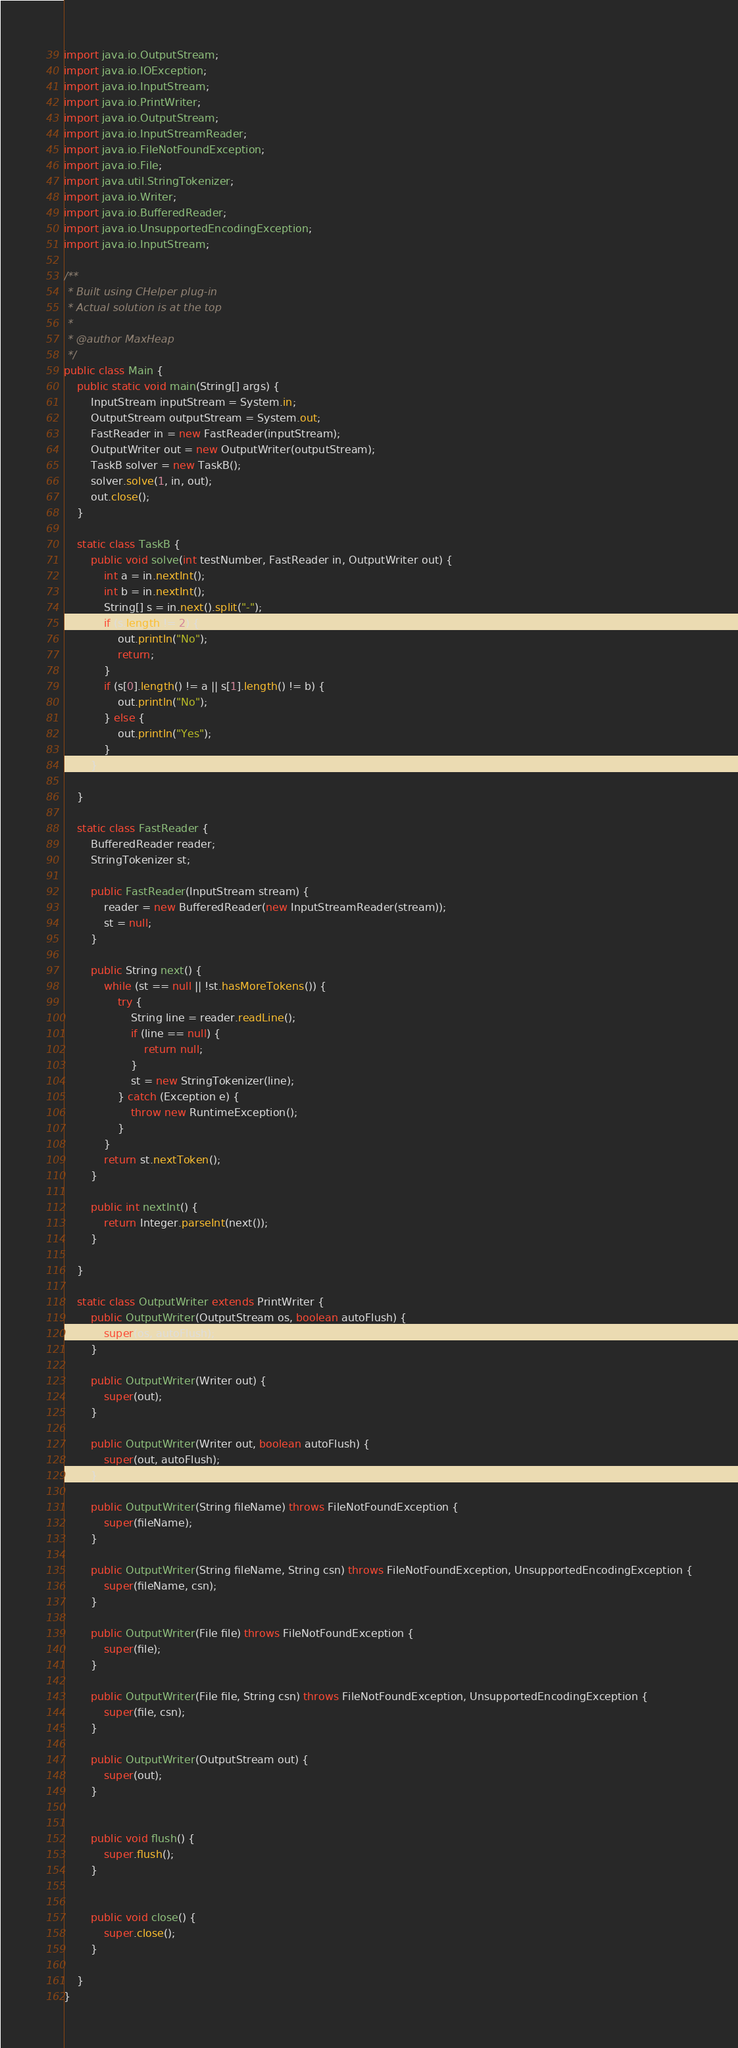Convert code to text. <code><loc_0><loc_0><loc_500><loc_500><_Java_>import java.io.OutputStream;
import java.io.IOException;
import java.io.InputStream;
import java.io.PrintWriter;
import java.io.OutputStream;
import java.io.InputStreamReader;
import java.io.FileNotFoundException;
import java.io.File;
import java.util.StringTokenizer;
import java.io.Writer;
import java.io.BufferedReader;
import java.io.UnsupportedEncodingException;
import java.io.InputStream;

/**
 * Built using CHelper plug-in
 * Actual solution is at the top
 *
 * @author MaxHeap
 */
public class Main {
    public static void main(String[] args) {
        InputStream inputStream = System.in;
        OutputStream outputStream = System.out;
        FastReader in = new FastReader(inputStream);
        OutputWriter out = new OutputWriter(outputStream);
        TaskB solver = new TaskB();
        solver.solve(1, in, out);
        out.close();
    }

    static class TaskB {
        public void solve(int testNumber, FastReader in, OutputWriter out) {
            int a = in.nextInt();
            int b = in.nextInt();
            String[] s = in.next().split("-");
            if (s.length != 2) {
                out.println("No");
                return;
            }
            if (s[0].length() != a || s[1].length() != b) {
                out.println("No");
            } else {
                out.println("Yes");
            }
        }

    }

    static class FastReader {
        BufferedReader reader;
        StringTokenizer st;

        public FastReader(InputStream stream) {
            reader = new BufferedReader(new InputStreamReader(stream));
            st = null;
        }

        public String next() {
            while (st == null || !st.hasMoreTokens()) {
                try {
                    String line = reader.readLine();
                    if (line == null) {
                        return null;
                    }
                    st = new StringTokenizer(line);
                } catch (Exception e) {
                    throw new RuntimeException();
                }
            }
            return st.nextToken();
        }

        public int nextInt() {
            return Integer.parseInt(next());
        }

    }

    static class OutputWriter extends PrintWriter {
        public OutputWriter(OutputStream os, boolean autoFlush) {
            super(os, autoFlush);
        }

        public OutputWriter(Writer out) {
            super(out);
        }

        public OutputWriter(Writer out, boolean autoFlush) {
            super(out, autoFlush);
        }

        public OutputWriter(String fileName) throws FileNotFoundException {
            super(fileName);
        }

        public OutputWriter(String fileName, String csn) throws FileNotFoundException, UnsupportedEncodingException {
            super(fileName, csn);
        }

        public OutputWriter(File file) throws FileNotFoundException {
            super(file);
        }

        public OutputWriter(File file, String csn) throws FileNotFoundException, UnsupportedEncodingException {
            super(file, csn);
        }

        public OutputWriter(OutputStream out) {
            super(out);
        }


        public void flush() {
            super.flush();
        }


        public void close() {
            super.close();
        }

    }
}

</code> 